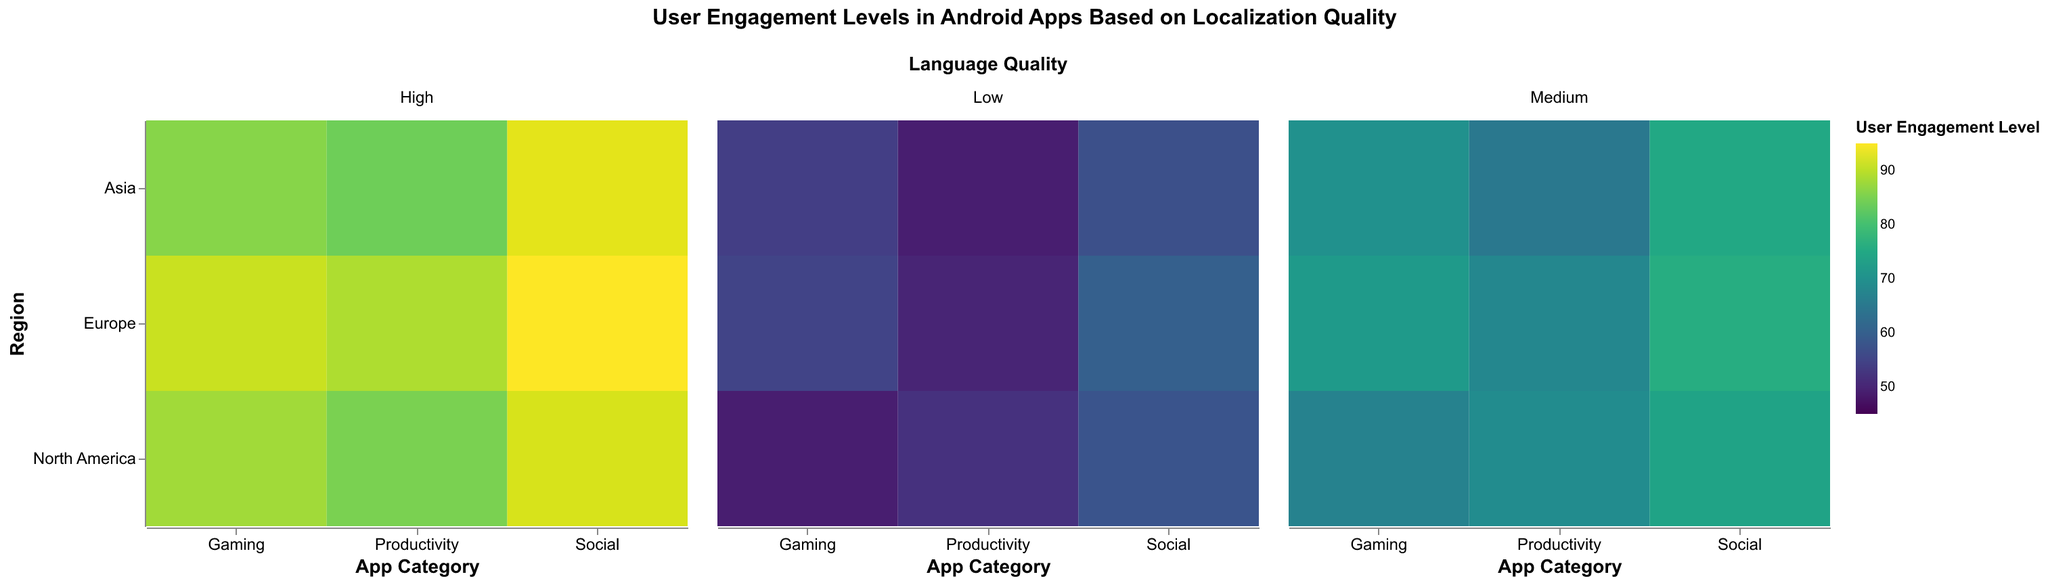What is the title of the heatmap? The title is located at the top center of the heatmap and it reads "User Engagement Levels in Android Apps Based on Localization Quality".
Answer: User Engagement Levels in Android Apps Based on Localization Quality What are the axis labels of the heatmap? The x-axis is labeled "App Category" and the y-axis is labeled "Region".
Answer: App Category, Region How many regions are displayed in the heatmap? The y-axis lists all regions, which include North America, Europe, and Asia, so there are three regions in total.
Answer: Three What's the average User Engagement Level for high language quality social apps across all regions? According to the heatmap data for high language quality social apps, the User Engagement Levels are: North America (92), Europe (95), Asia (93). Sum these values and divide by the number of values to get the average: (92 + 95 + 93) / 3 = 280 / 3 = 93.33
Answer: 93.33 How much higher is the User Engagement Level for high language quality gaming apps in Europe compared to North America? The User Engagement Level for high language quality gaming apps in Europe is 91 and in North America it is 88. The difference is calculated as 91 - 88 = 3.
Answer: 3 Which app category in Asia has the lowest User Engagement Level for low language quality? Looking at the heatmap data, in Asia for low language quality, Social (57), Gaming (54), and Productivity (49). The lowest value is 49 for Productivity.
Answer: Productivity In which region and app category is the User Engagement Level highest for medium language quality? For medium language quality across all regions and app categories: North America (Social 74, Gaming 67, Productivity 69), Europe (Social 76, Gaming 72, Productivity 68), Asia (Social 75, Gaming 70, Productivity 65). The highest value is 76 for Social in Europe.
Answer: Europe, Social For which combination of region, language quality, and app category do we see the brightest green color? The brightest green color represents the highest User Engagement Level. The data shows the highest value of 95 for high language quality social apps in Europe.
Answer: Europe, High, Social 